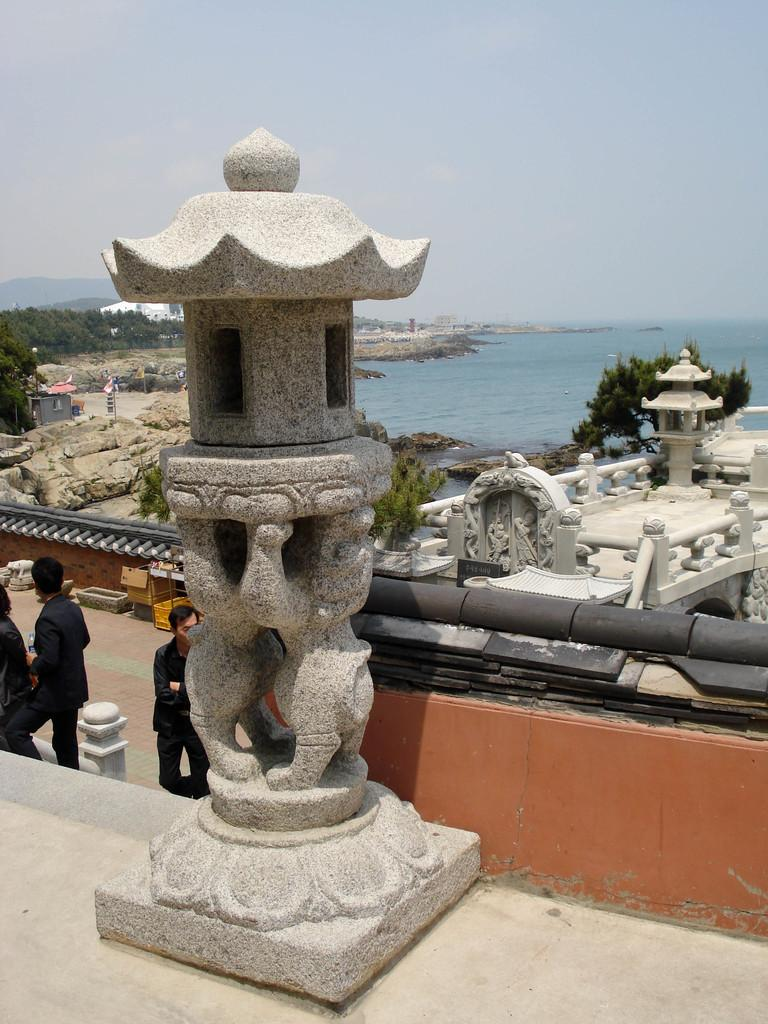What is the main subject of the image? There is a sculpture in the image. How many people are in the image? There are three persons in the image. What type of natural elements can be seen in the image? There are trees and rocks visible in the image. What is the water feature in the image? There is water visible in the image. What can be seen in the background of the image? The sky is visible in the background of the image. Where is the library located in the image? There is no library present in the image. What type of locket can be seen around the neck of one of the persons in the image? There is no locket visible around the neck of any person in the image. 